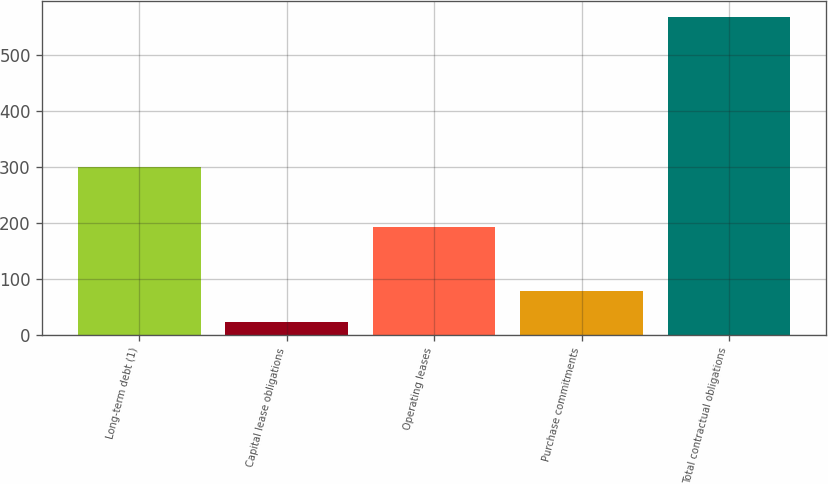<chart> <loc_0><loc_0><loc_500><loc_500><bar_chart><fcel>Long-term debt (1)<fcel>Capital lease obligations<fcel>Operating leases<fcel>Purchase commitments<fcel>Total contractual obligations<nl><fcel>299<fcel>24<fcel>192<fcel>78.3<fcel>567<nl></chart> 